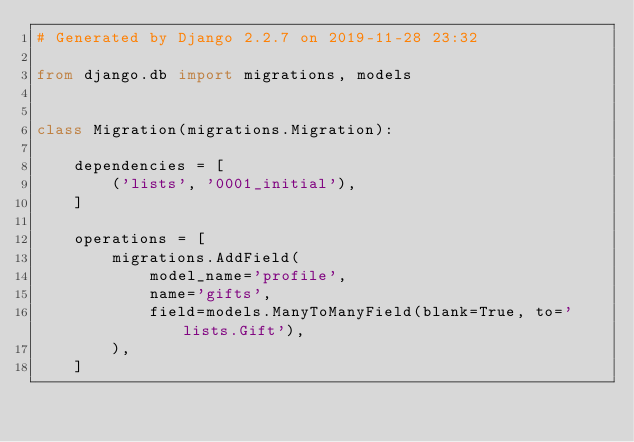<code> <loc_0><loc_0><loc_500><loc_500><_Python_># Generated by Django 2.2.7 on 2019-11-28 23:32

from django.db import migrations, models


class Migration(migrations.Migration):

    dependencies = [
        ('lists', '0001_initial'),
    ]

    operations = [
        migrations.AddField(
            model_name='profile',
            name='gifts',
            field=models.ManyToManyField(blank=True, to='lists.Gift'),
        ),
    ]
</code> 